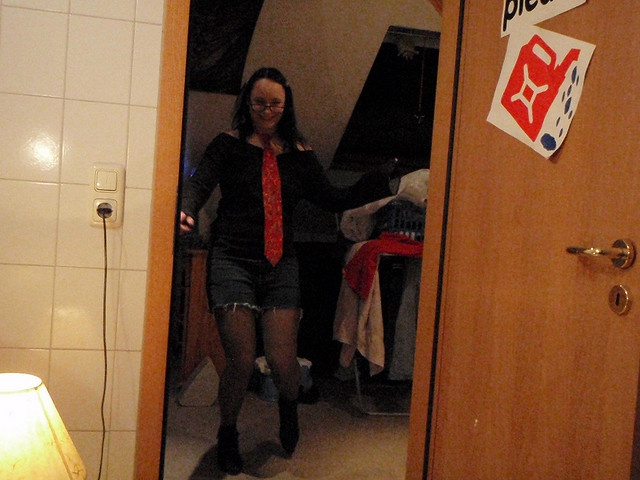Describe the objects in this image and their specific colors. I can see people in tan, black, and maroon tones and tie in tan, maroon, black, and brown tones in this image. 